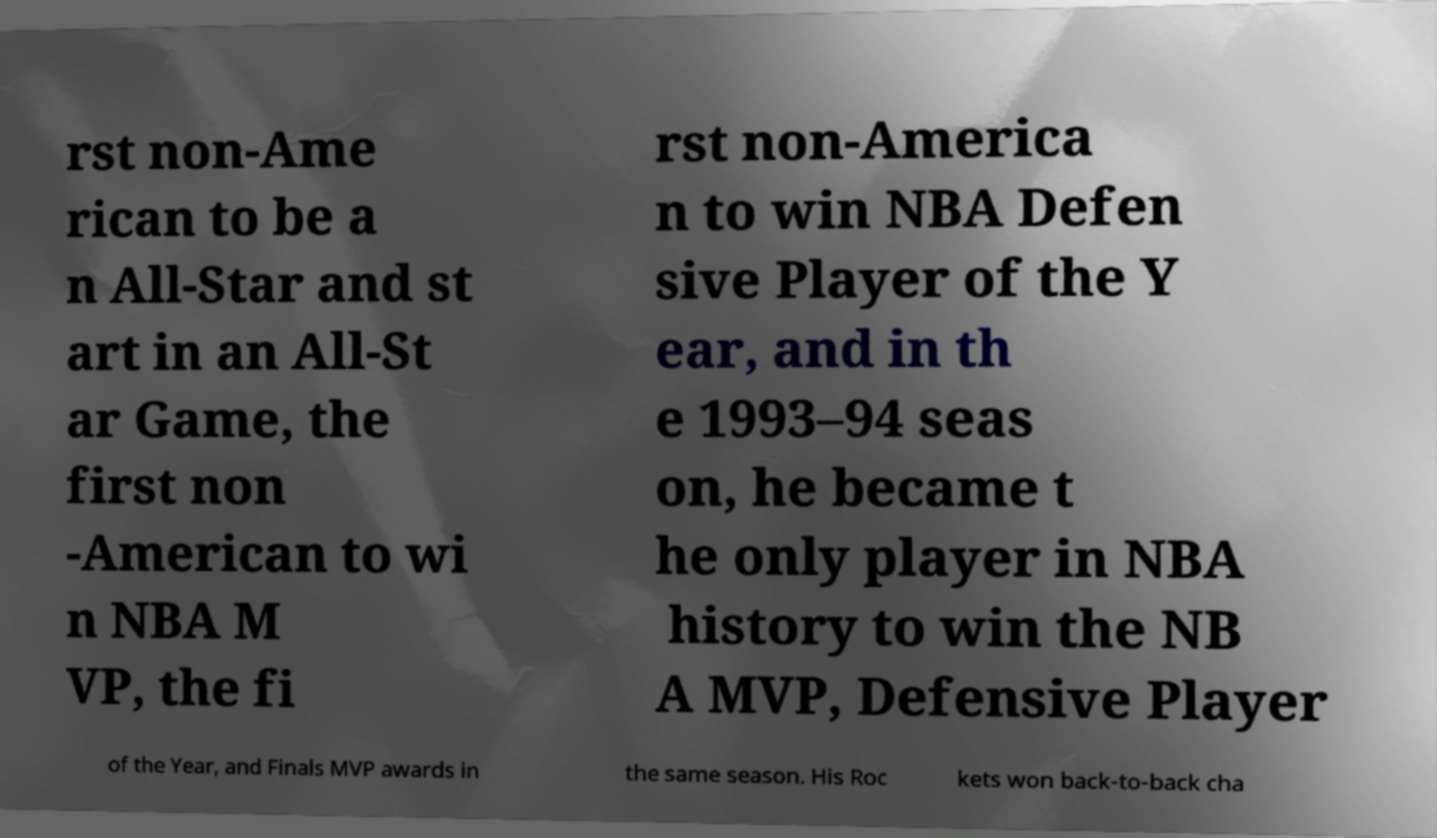Could you extract and type out the text from this image? rst non-Ame rican to be a n All-Star and st art in an All-St ar Game, the first non -American to wi n NBA M VP, the fi rst non-America n to win NBA Defen sive Player of the Y ear, and in th e 1993–94 seas on, he became t he only player in NBA history to win the NB A MVP, Defensive Player of the Year, and Finals MVP awards in the same season. His Roc kets won back-to-back cha 